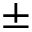Convert formula to latex. <formula><loc_0><loc_0><loc_500><loc_500>\pm</formula> 